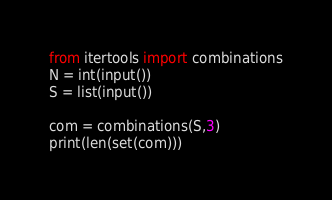<code> <loc_0><loc_0><loc_500><loc_500><_Python_>from itertools import combinations
N = int(input())
S = list(input())

com = combinations(S,3)
print(len(set(com)))</code> 